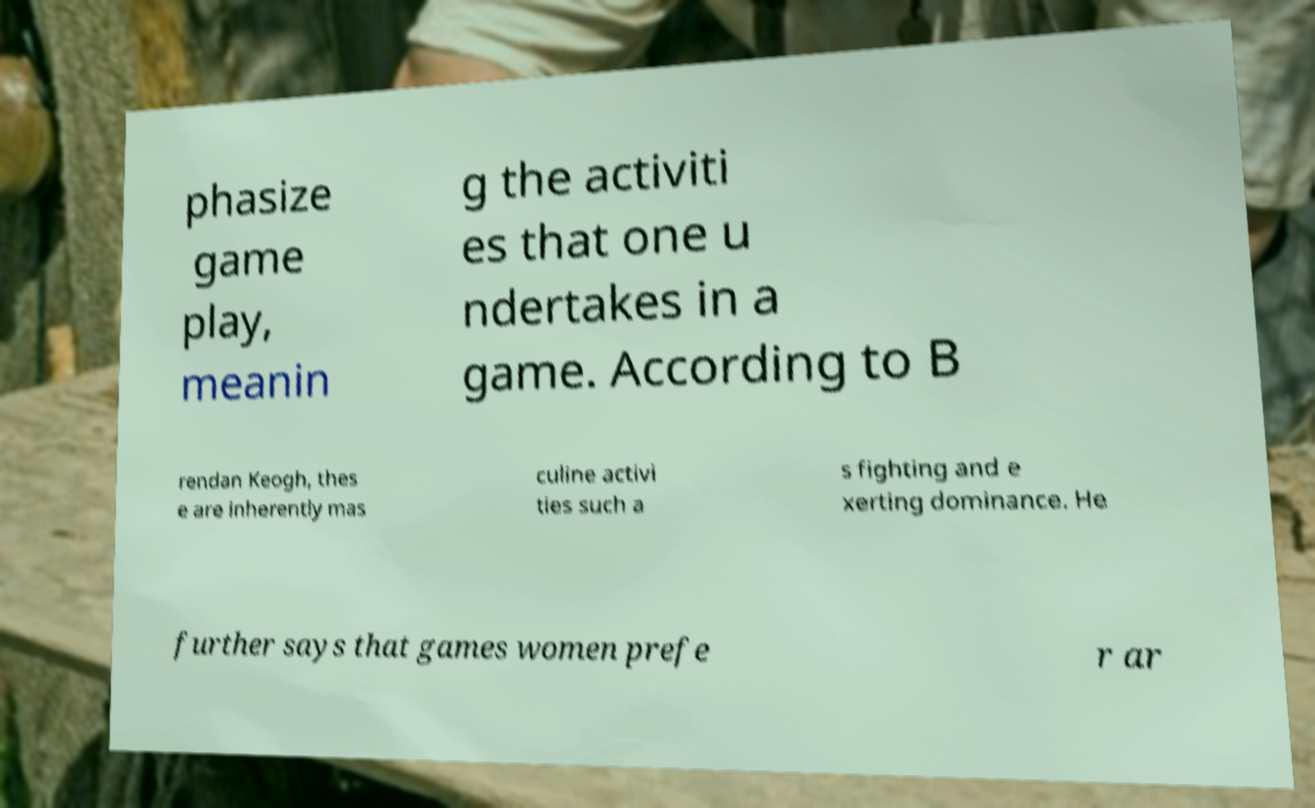Please identify and transcribe the text found in this image. phasize game play, meanin g the activiti es that one u ndertakes in a game. According to B rendan Keogh, thes e are inherently mas culine activi ties such a s fighting and e xerting dominance. He further says that games women prefe r ar 